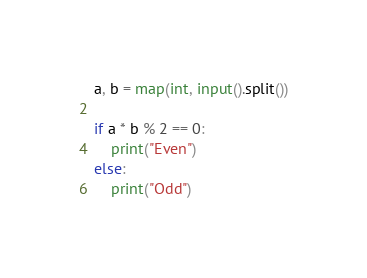<code> <loc_0><loc_0><loc_500><loc_500><_Python_>a, b = map(int, input().split())

if a * b % 2 == 0:
    print("Even")
else:
    print("Odd")</code> 